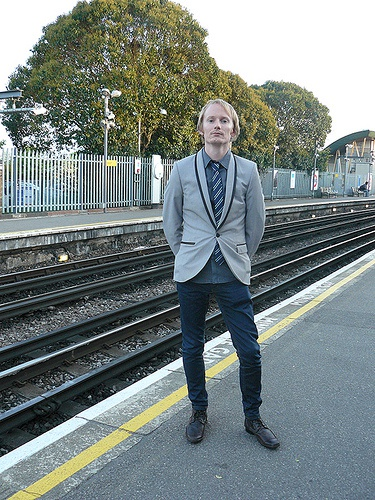Describe the objects in this image and their specific colors. I can see people in white, black, darkgray, and navy tones, tie in white, navy, black, blue, and lightblue tones, bench in white, darkgray, gray, and lightgray tones, people in white, black, blue, navy, and gray tones, and bench in white, darkgray, gray, lightgray, and blue tones in this image. 